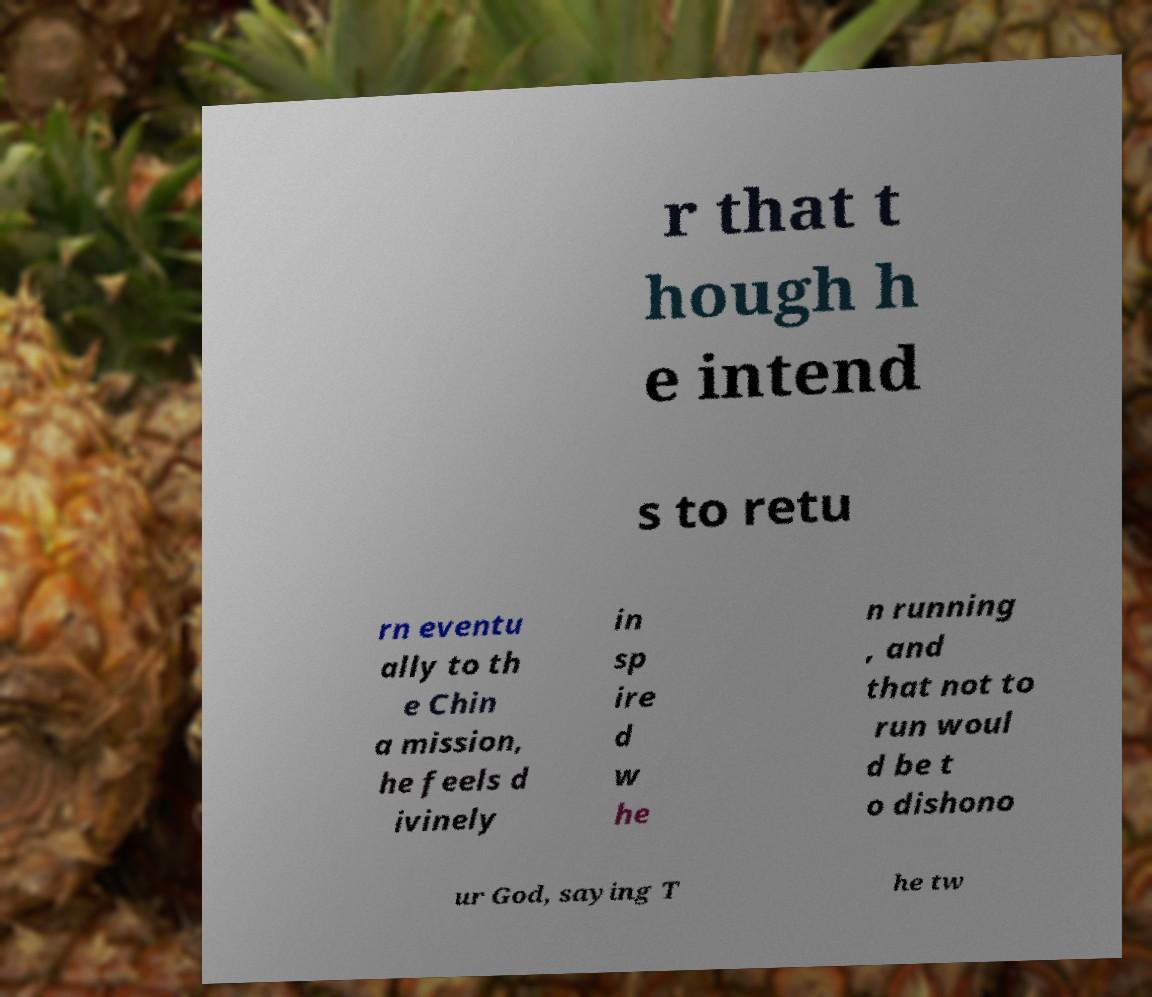Can you read and provide the text displayed in the image?This photo seems to have some interesting text. Can you extract and type it out for me? r that t hough h e intend s to retu rn eventu ally to th e Chin a mission, he feels d ivinely in sp ire d w he n running , and that not to run woul d be t o dishono ur God, saying T he tw 